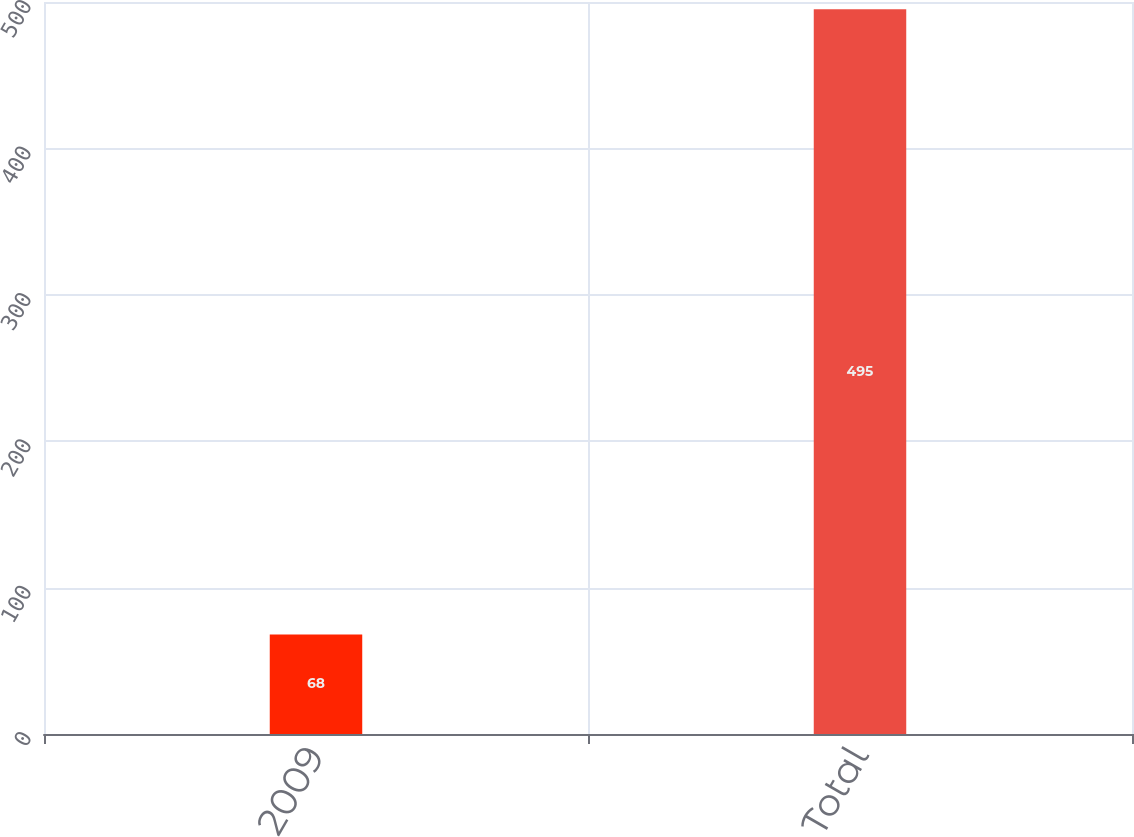Convert chart. <chart><loc_0><loc_0><loc_500><loc_500><bar_chart><fcel>2009<fcel>Total<nl><fcel>68<fcel>495<nl></chart> 